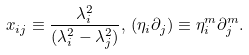<formula> <loc_0><loc_0><loc_500><loc_500>x _ { i j } \equiv \frac { \lambda _ { i } ^ { 2 } } { ( \lambda _ { i } ^ { 2 } - \lambda _ { j } ^ { 2 } ) } , \, ( \eta _ { i } \partial _ { j } ) \equiv \eta ^ { m } _ { i } \partial ^ { m } _ { j } .</formula> 